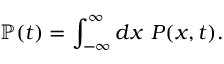Convert formula to latex. <formula><loc_0><loc_0><loc_500><loc_500>\mathbb { P } ( t ) = \int _ { - \infty } ^ { \infty } d x \ P ( x , t ) .</formula> 